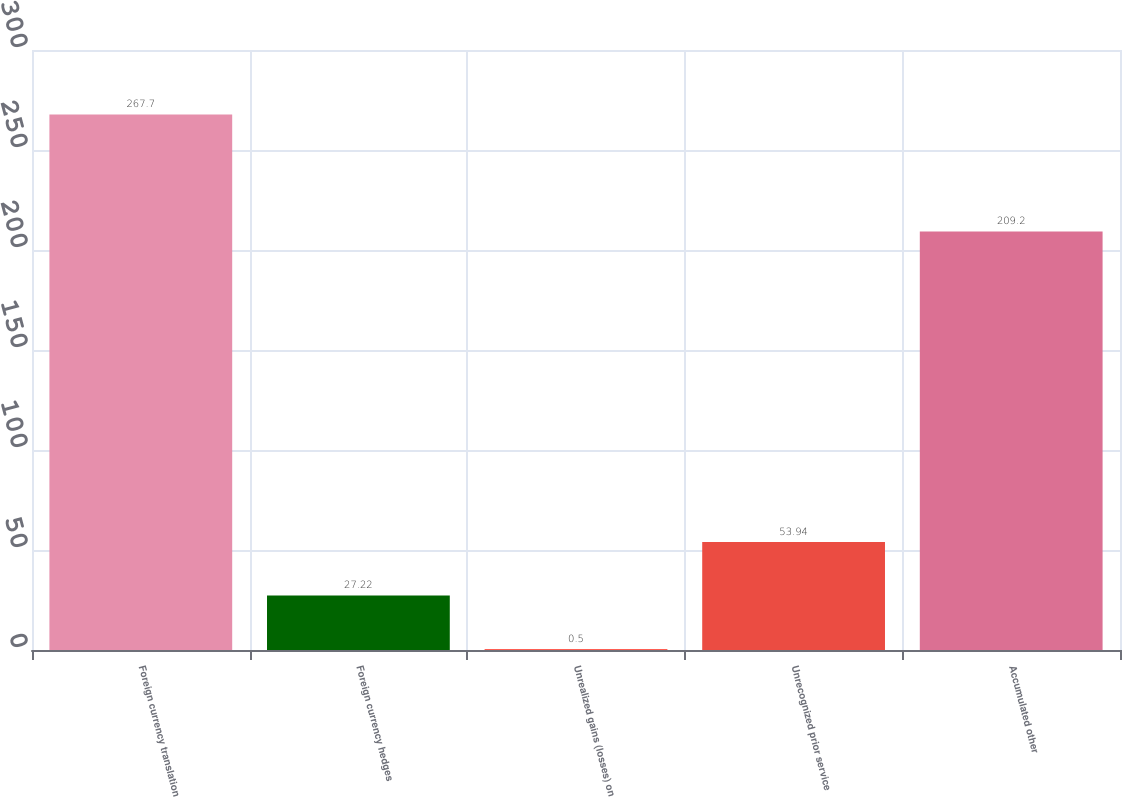<chart> <loc_0><loc_0><loc_500><loc_500><bar_chart><fcel>Foreign currency translation<fcel>Foreign currency hedges<fcel>Unrealized gains (losses) on<fcel>Unrecognized prior service<fcel>Accumulated other<nl><fcel>267.7<fcel>27.22<fcel>0.5<fcel>53.94<fcel>209.2<nl></chart> 